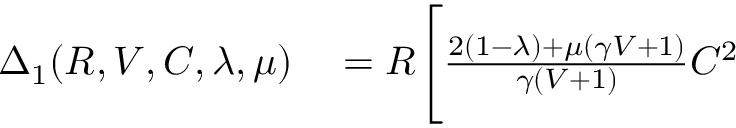Convert formula to latex. <formula><loc_0><loc_0><loc_500><loc_500>\begin{array} { r l } { \Delta _ { 1 } ( R , V , C , \lambda , \mu ) } & = R \Big [ \frac { 2 ( 1 - \lambda ) + \mu ( \gamma V + 1 ) } { \gamma ( V + 1 ) } C ^ { 2 } } \end{array}</formula> 